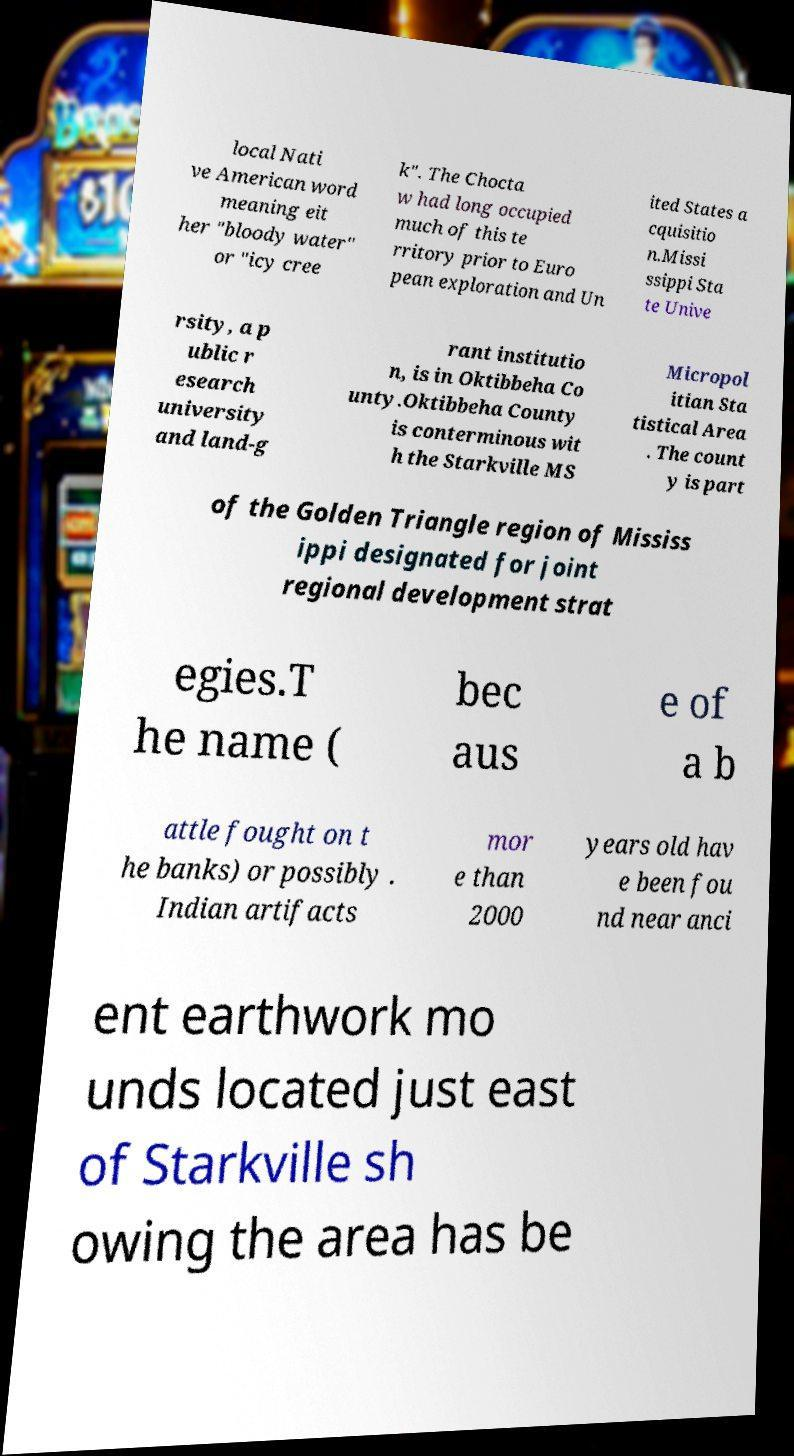Could you assist in decoding the text presented in this image and type it out clearly? local Nati ve American word meaning eit her "bloody water" or "icy cree k". The Chocta w had long occupied much of this te rritory prior to Euro pean exploration and Un ited States a cquisitio n.Missi ssippi Sta te Unive rsity, a p ublic r esearch university and land-g rant institutio n, is in Oktibbeha Co unty.Oktibbeha County is conterminous wit h the Starkville MS Micropol itian Sta tistical Area . The count y is part of the Golden Triangle region of Mississ ippi designated for joint regional development strat egies.T he name ( bec aus e of a b attle fought on t he banks) or possibly . Indian artifacts mor e than 2000 years old hav e been fou nd near anci ent earthwork mo unds located just east of Starkville sh owing the area has be 